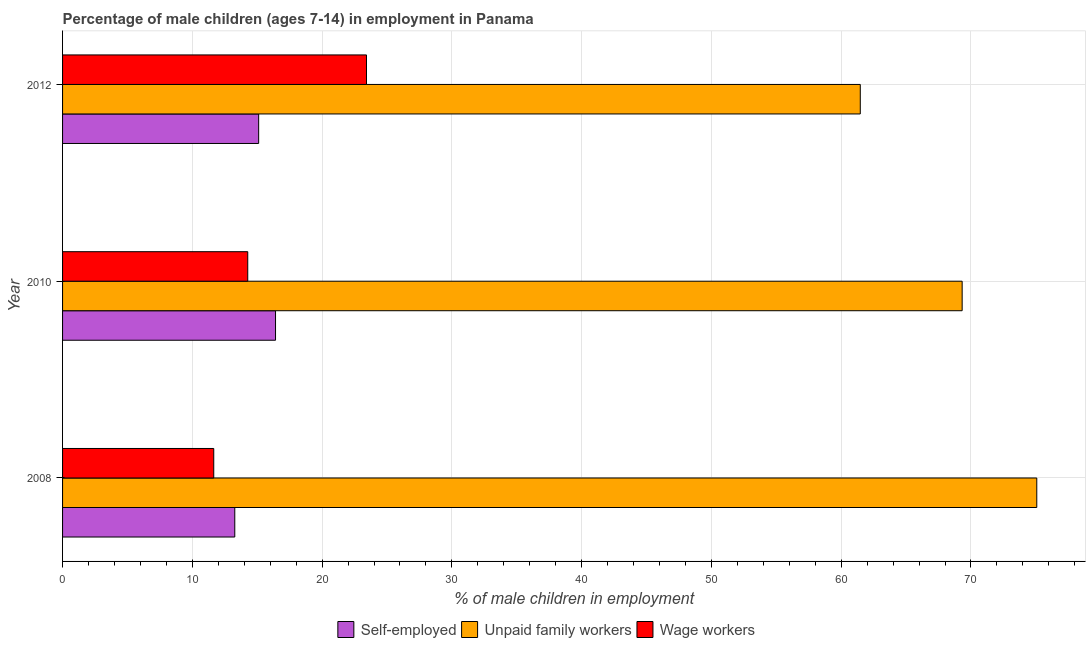How many different coloured bars are there?
Your answer should be compact. 3. Are the number of bars on each tick of the Y-axis equal?
Give a very brief answer. Yes. What is the percentage of self employed children in 2012?
Ensure brevity in your answer.  15.11. Across all years, what is the maximum percentage of self employed children?
Offer a very short reply. 16.41. Across all years, what is the minimum percentage of children employed as unpaid family workers?
Offer a terse response. 61.47. In which year was the percentage of self employed children minimum?
Offer a very short reply. 2008. What is the total percentage of children employed as unpaid family workers in the graph?
Your answer should be very brief. 205.86. What is the difference between the percentage of children employed as unpaid family workers in 2010 and that in 2012?
Make the answer very short. 7.85. What is the difference between the percentage of self employed children in 2008 and the percentage of children employed as wage workers in 2012?
Offer a terse response. -10.15. What is the average percentage of children employed as unpaid family workers per year?
Offer a very short reply. 68.62. In the year 2010, what is the difference between the percentage of children employed as wage workers and percentage of self employed children?
Ensure brevity in your answer.  -2.14. In how many years, is the percentage of self employed children greater than 68 %?
Your answer should be compact. 0. What is the ratio of the percentage of self employed children in 2008 to that in 2012?
Offer a very short reply. 0.88. Is the percentage of self employed children in 2008 less than that in 2010?
Make the answer very short. Yes. Is the difference between the percentage of children employed as unpaid family workers in 2008 and 2012 greater than the difference between the percentage of children employed as wage workers in 2008 and 2012?
Make the answer very short. Yes. What is the difference between the highest and the second highest percentage of children employed as unpaid family workers?
Ensure brevity in your answer.  5.75. What is the difference between the highest and the lowest percentage of children employed as unpaid family workers?
Keep it short and to the point. 13.6. Is the sum of the percentage of children employed as wage workers in 2008 and 2012 greater than the maximum percentage of children employed as unpaid family workers across all years?
Offer a very short reply. No. What does the 3rd bar from the top in 2010 represents?
Offer a very short reply. Self-employed. What does the 2nd bar from the bottom in 2012 represents?
Your answer should be very brief. Unpaid family workers. Is it the case that in every year, the sum of the percentage of self employed children and percentage of children employed as unpaid family workers is greater than the percentage of children employed as wage workers?
Offer a terse response. Yes. How many bars are there?
Keep it short and to the point. 9. Are all the bars in the graph horizontal?
Provide a succinct answer. Yes. How many years are there in the graph?
Give a very brief answer. 3. What is the difference between two consecutive major ticks on the X-axis?
Keep it short and to the point. 10. Are the values on the major ticks of X-axis written in scientific E-notation?
Make the answer very short. No. Does the graph contain grids?
Provide a short and direct response. Yes. What is the title of the graph?
Give a very brief answer. Percentage of male children (ages 7-14) in employment in Panama. What is the label or title of the X-axis?
Your answer should be compact. % of male children in employment. What is the % of male children in employment in Self-employed in 2008?
Give a very brief answer. 13.27. What is the % of male children in employment in Unpaid family workers in 2008?
Provide a succinct answer. 75.07. What is the % of male children in employment in Wage workers in 2008?
Your answer should be very brief. 11.65. What is the % of male children in employment in Self-employed in 2010?
Provide a succinct answer. 16.41. What is the % of male children in employment in Unpaid family workers in 2010?
Your response must be concise. 69.32. What is the % of male children in employment of Wage workers in 2010?
Provide a short and direct response. 14.27. What is the % of male children in employment in Self-employed in 2012?
Keep it short and to the point. 15.11. What is the % of male children in employment in Unpaid family workers in 2012?
Offer a very short reply. 61.47. What is the % of male children in employment of Wage workers in 2012?
Give a very brief answer. 23.42. Across all years, what is the maximum % of male children in employment in Self-employed?
Keep it short and to the point. 16.41. Across all years, what is the maximum % of male children in employment in Unpaid family workers?
Your answer should be very brief. 75.07. Across all years, what is the maximum % of male children in employment in Wage workers?
Your response must be concise. 23.42. Across all years, what is the minimum % of male children in employment in Self-employed?
Provide a short and direct response. 13.27. Across all years, what is the minimum % of male children in employment of Unpaid family workers?
Give a very brief answer. 61.47. Across all years, what is the minimum % of male children in employment of Wage workers?
Your answer should be compact. 11.65. What is the total % of male children in employment of Self-employed in the graph?
Offer a very short reply. 44.79. What is the total % of male children in employment in Unpaid family workers in the graph?
Provide a succinct answer. 205.86. What is the total % of male children in employment of Wage workers in the graph?
Your answer should be very brief. 49.34. What is the difference between the % of male children in employment of Self-employed in 2008 and that in 2010?
Ensure brevity in your answer.  -3.14. What is the difference between the % of male children in employment in Unpaid family workers in 2008 and that in 2010?
Keep it short and to the point. 5.75. What is the difference between the % of male children in employment of Wage workers in 2008 and that in 2010?
Offer a very short reply. -2.62. What is the difference between the % of male children in employment in Self-employed in 2008 and that in 2012?
Your answer should be very brief. -1.84. What is the difference between the % of male children in employment in Unpaid family workers in 2008 and that in 2012?
Your answer should be compact. 13.6. What is the difference between the % of male children in employment in Wage workers in 2008 and that in 2012?
Your answer should be compact. -11.77. What is the difference between the % of male children in employment of Self-employed in 2010 and that in 2012?
Keep it short and to the point. 1.3. What is the difference between the % of male children in employment in Unpaid family workers in 2010 and that in 2012?
Offer a very short reply. 7.85. What is the difference between the % of male children in employment of Wage workers in 2010 and that in 2012?
Offer a terse response. -9.15. What is the difference between the % of male children in employment in Self-employed in 2008 and the % of male children in employment in Unpaid family workers in 2010?
Provide a short and direct response. -56.05. What is the difference between the % of male children in employment in Self-employed in 2008 and the % of male children in employment in Wage workers in 2010?
Ensure brevity in your answer.  -1. What is the difference between the % of male children in employment of Unpaid family workers in 2008 and the % of male children in employment of Wage workers in 2010?
Give a very brief answer. 60.8. What is the difference between the % of male children in employment of Self-employed in 2008 and the % of male children in employment of Unpaid family workers in 2012?
Your answer should be very brief. -48.2. What is the difference between the % of male children in employment in Self-employed in 2008 and the % of male children in employment in Wage workers in 2012?
Provide a succinct answer. -10.15. What is the difference between the % of male children in employment of Unpaid family workers in 2008 and the % of male children in employment of Wage workers in 2012?
Ensure brevity in your answer.  51.65. What is the difference between the % of male children in employment of Self-employed in 2010 and the % of male children in employment of Unpaid family workers in 2012?
Your answer should be compact. -45.06. What is the difference between the % of male children in employment of Self-employed in 2010 and the % of male children in employment of Wage workers in 2012?
Provide a short and direct response. -7.01. What is the difference between the % of male children in employment in Unpaid family workers in 2010 and the % of male children in employment in Wage workers in 2012?
Give a very brief answer. 45.9. What is the average % of male children in employment of Self-employed per year?
Make the answer very short. 14.93. What is the average % of male children in employment of Unpaid family workers per year?
Your answer should be compact. 68.62. What is the average % of male children in employment in Wage workers per year?
Ensure brevity in your answer.  16.45. In the year 2008, what is the difference between the % of male children in employment in Self-employed and % of male children in employment in Unpaid family workers?
Keep it short and to the point. -61.8. In the year 2008, what is the difference between the % of male children in employment of Self-employed and % of male children in employment of Wage workers?
Provide a short and direct response. 1.62. In the year 2008, what is the difference between the % of male children in employment of Unpaid family workers and % of male children in employment of Wage workers?
Your answer should be very brief. 63.42. In the year 2010, what is the difference between the % of male children in employment of Self-employed and % of male children in employment of Unpaid family workers?
Ensure brevity in your answer.  -52.91. In the year 2010, what is the difference between the % of male children in employment of Self-employed and % of male children in employment of Wage workers?
Make the answer very short. 2.14. In the year 2010, what is the difference between the % of male children in employment in Unpaid family workers and % of male children in employment in Wage workers?
Ensure brevity in your answer.  55.05. In the year 2012, what is the difference between the % of male children in employment in Self-employed and % of male children in employment in Unpaid family workers?
Ensure brevity in your answer.  -46.36. In the year 2012, what is the difference between the % of male children in employment in Self-employed and % of male children in employment in Wage workers?
Offer a very short reply. -8.31. In the year 2012, what is the difference between the % of male children in employment in Unpaid family workers and % of male children in employment in Wage workers?
Your answer should be very brief. 38.05. What is the ratio of the % of male children in employment in Self-employed in 2008 to that in 2010?
Keep it short and to the point. 0.81. What is the ratio of the % of male children in employment in Unpaid family workers in 2008 to that in 2010?
Ensure brevity in your answer.  1.08. What is the ratio of the % of male children in employment in Wage workers in 2008 to that in 2010?
Offer a very short reply. 0.82. What is the ratio of the % of male children in employment of Self-employed in 2008 to that in 2012?
Offer a terse response. 0.88. What is the ratio of the % of male children in employment of Unpaid family workers in 2008 to that in 2012?
Offer a terse response. 1.22. What is the ratio of the % of male children in employment of Wage workers in 2008 to that in 2012?
Provide a short and direct response. 0.5. What is the ratio of the % of male children in employment in Self-employed in 2010 to that in 2012?
Offer a very short reply. 1.09. What is the ratio of the % of male children in employment of Unpaid family workers in 2010 to that in 2012?
Ensure brevity in your answer.  1.13. What is the ratio of the % of male children in employment of Wage workers in 2010 to that in 2012?
Provide a succinct answer. 0.61. What is the difference between the highest and the second highest % of male children in employment in Self-employed?
Make the answer very short. 1.3. What is the difference between the highest and the second highest % of male children in employment in Unpaid family workers?
Your answer should be compact. 5.75. What is the difference between the highest and the second highest % of male children in employment of Wage workers?
Offer a terse response. 9.15. What is the difference between the highest and the lowest % of male children in employment in Self-employed?
Your response must be concise. 3.14. What is the difference between the highest and the lowest % of male children in employment of Wage workers?
Offer a very short reply. 11.77. 